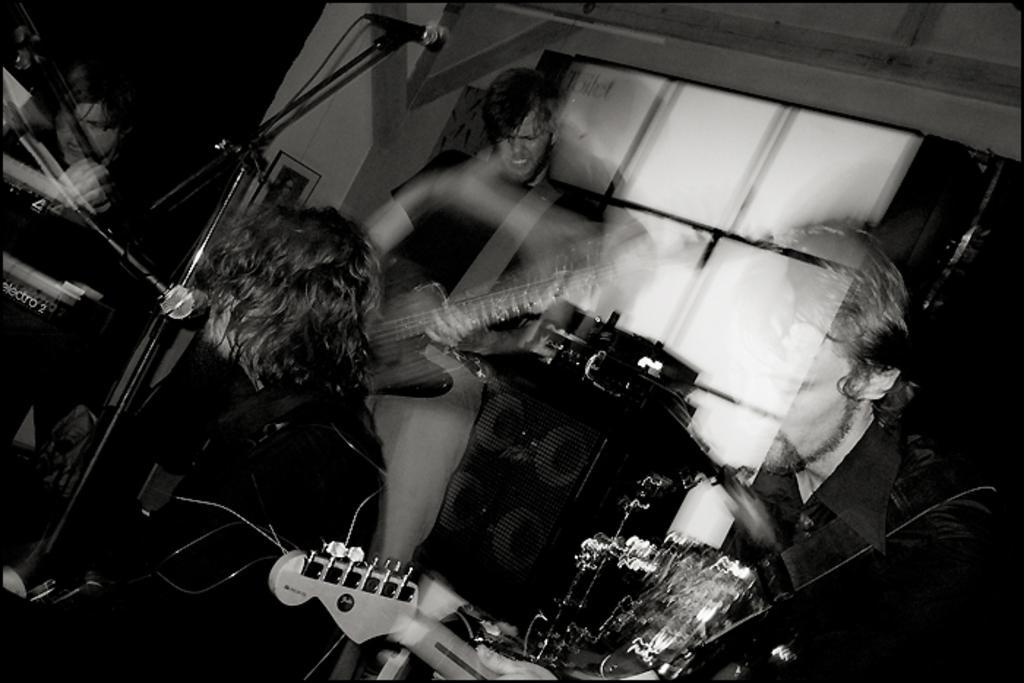How would you summarize this image in a sentence or two? There are four persons. They are playing guitar. There are mics and mic stands. In the background there is a window. 